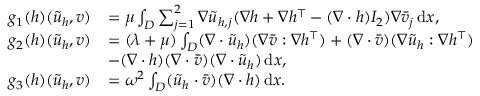<formula> <loc_0><loc_0><loc_500><loc_500>\begin{array} { r l } { g _ { 1 } ( h ) ( \tilde { u } _ { h } , v ) } & { = \mu \int _ { D } \sum _ { j = 1 } ^ { 2 } \nabla \tilde { u } _ { h , j } ( \nabla h + \nabla h ^ { \top } - ( \nabla \cdot h ) I _ { 2 } ) \nabla \bar { v } _ { j } \, d x , } \\ { g _ { 2 } ( h ) ( \tilde { u } _ { h } , v ) } & { = ( \lambda + \mu ) \int _ { D } ( \nabla \cdot \tilde { u } _ { h } ) ( \nabla \bar { v } \colon \nabla h ^ { \top } ) + ( \nabla \cdot \bar { v } ) ( \nabla \tilde { u } _ { h } \colon \nabla h ^ { \top } ) } \\ & { - ( \nabla \cdot h ) ( \nabla \cdot \bar { v } ) ( \nabla \cdot \tilde { u } _ { h } ) \, d x , } \\ { g _ { 3 } ( h ) ( \tilde { u } _ { h } , v ) } & { = \omega ^ { 2 } \int _ { D } ( \tilde { u } _ { h } \cdot \bar { v } ) ( \nabla \cdot h ) \, d x . } \end{array}</formula> 